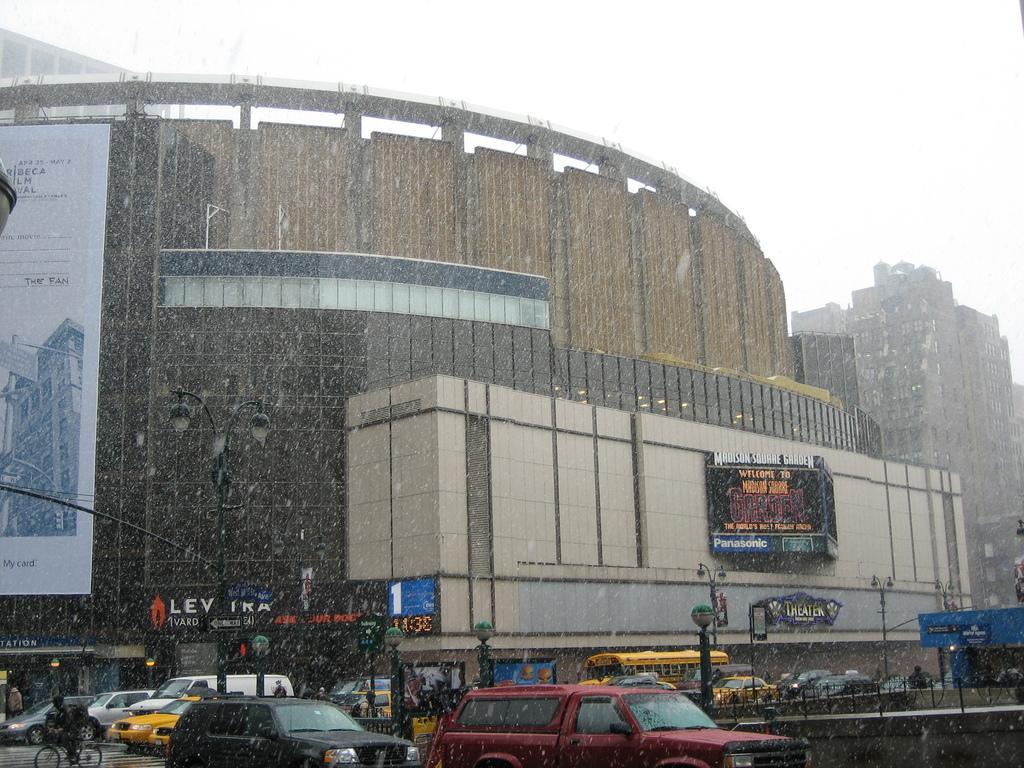Could you give a brief overview of what you see in this image? In this image, we can see vehicles on the road and we can see people and there is a person riding bicycle. In the background, there are buildings, boards, poles, lights and we can see railings. At the top, there is sky. 